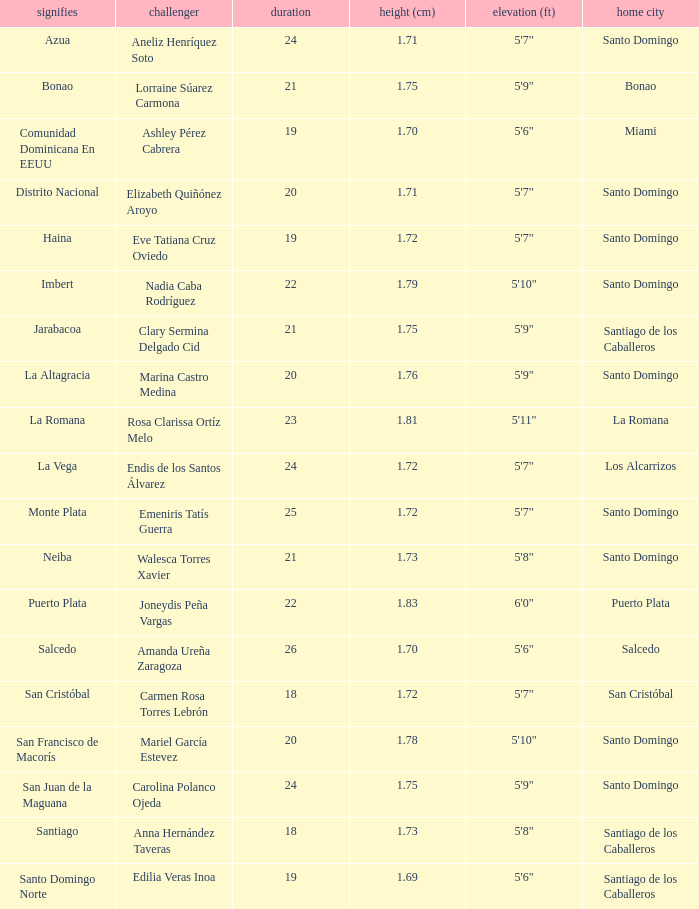Name the total number of represents for clary sermina delgado cid 1.0. 